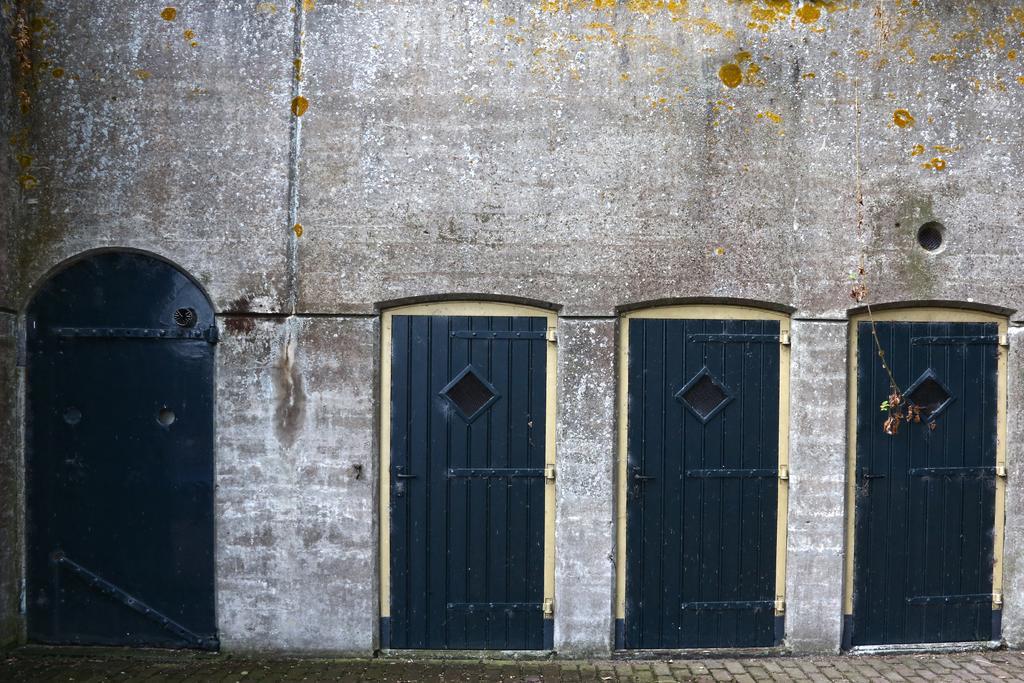Describe this image in one or two sentences. In this picture we can see few doors and a wall. 